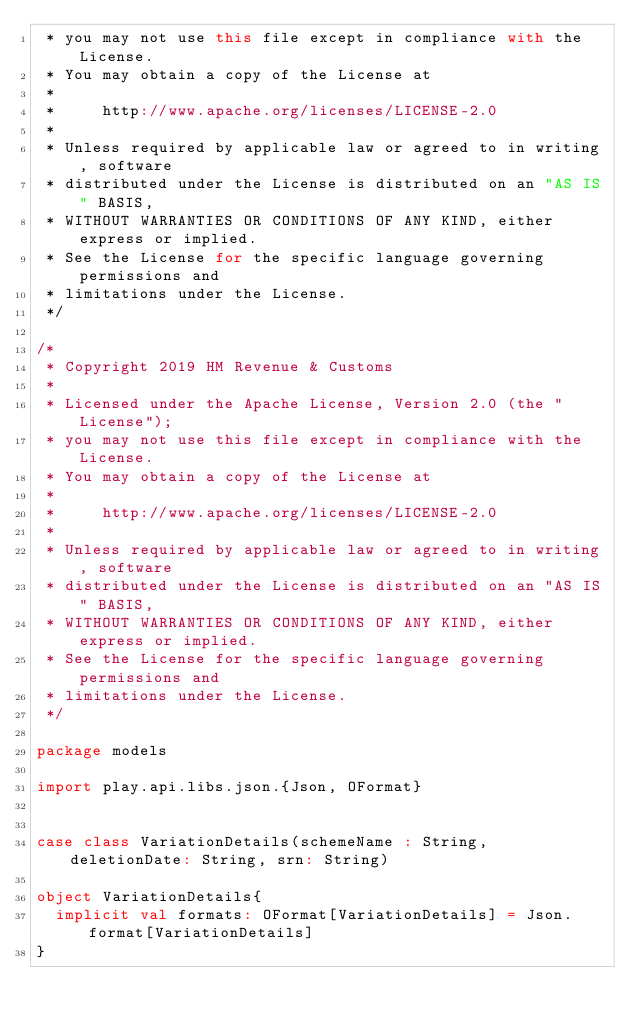Convert code to text. <code><loc_0><loc_0><loc_500><loc_500><_Scala_> * you may not use this file except in compliance with the License.
 * You may obtain a copy of the License at
 *
 *     http://www.apache.org/licenses/LICENSE-2.0
 *
 * Unless required by applicable law or agreed to in writing, software
 * distributed under the License is distributed on an "AS IS" BASIS,
 * WITHOUT WARRANTIES OR CONDITIONS OF ANY KIND, either express or implied.
 * See the License for the specific language governing permissions and
 * limitations under the License.
 */

/*
 * Copyright 2019 HM Revenue & Customs
 *
 * Licensed under the Apache License, Version 2.0 (the "License");
 * you may not use this file except in compliance with the License.
 * You may obtain a copy of the License at
 *
 *     http://www.apache.org/licenses/LICENSE-2.0
 *
 * Unless required by applicable law or agreed to in writing, software
 * distributed under the License is distributed on an "AS IS" BASIS,
 * WITHOUT WARRANTIES OR CONDITIONS OF ANY KIND, either express or implied.
 * See the License for the specific language governing permissions and
 * limitations under the License.
 */

package models

import play.api.libs.json.{Json, OFormat}


case class VariationDetails(schemeName : String, deletionDate: String, srn: String)

object VariationDetails{
  implicit val formats: OFormat[VariationDetails] = Json.format[VariationDetails]
}
</code> 